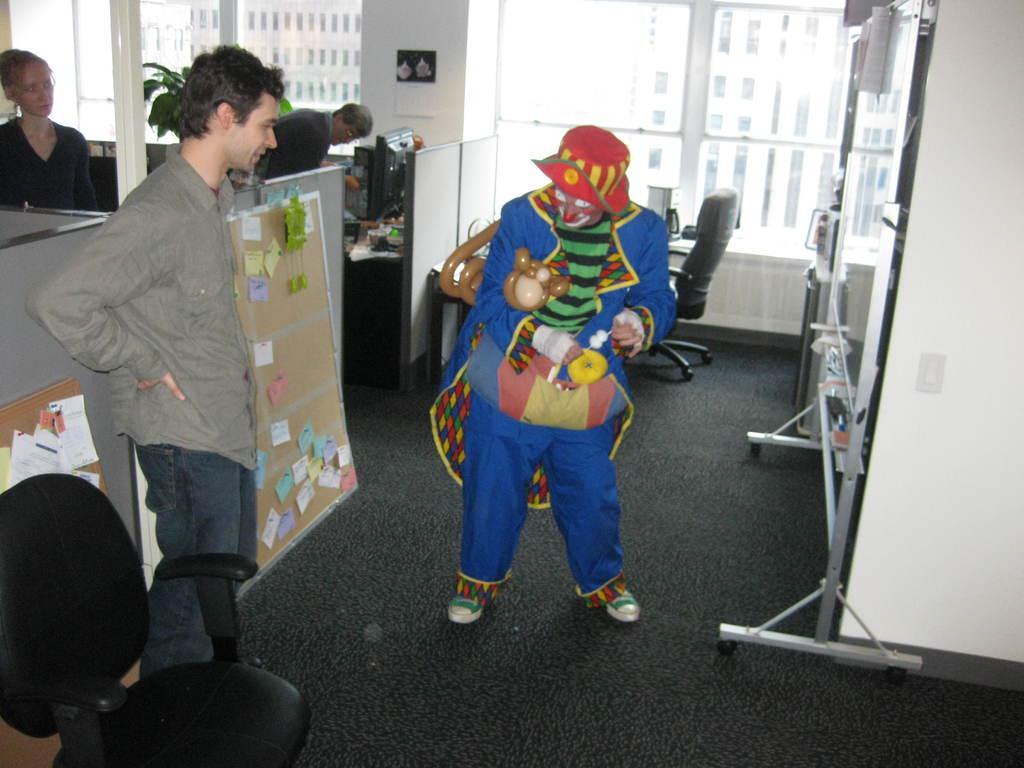Please provide a concise description of this image. The picture is inside an office. Here a person is standing wearing jokers costume. In the room there are tables, chairs, systems, cupboards,boards, sticky notes are there. Three people are here. Through the glass window we can see outside there are buildings. 